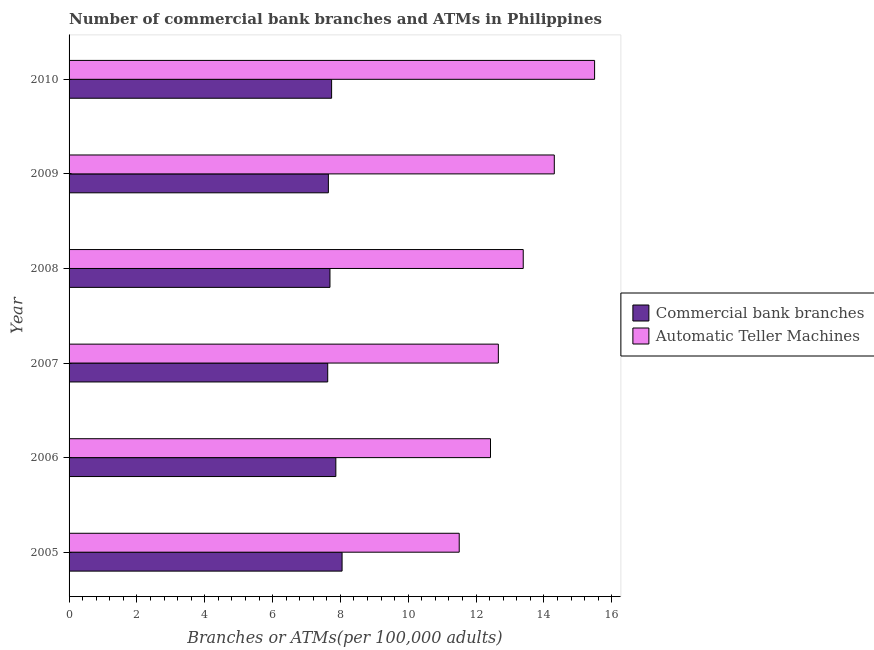How many different coloured bars are there?
Provide a succinct answer. 2. How many groups of bars are there?
Your answer should be very brief. 6. In how many cases, is the number of bars for a given year not equal to the number of legend labels?
Provide a short and direct response. 0. What is the number of commercal bank branches in 2009?
Make the answer very short. 7.65. Across all years, what is the maximum number of commercal bank branches?
Ensure brevity in your answer.  8.05. Across all years, what is the minimum number of commercal bank branches?
Your response must be concise. 7.63. In which year was the number of atms minimum?
Give a very brief answer. 2005. What is the total number of commercal bank branches in the graph?
Provide a succinct answer. 46.62. What is the difference between the number of commercal bank branches in 2008 and that in 2010?
Ensure brevity in your answer.  -0.05. What is the difference between the number of commercal bank branches in 2010 and the number of atms in 2009?
Make the answer very short. -6.57. What is the average number of commercal bank branches per year?
Your response must be concise. 7.77. In the year 2010, what is the difference between the number of commercal bank branches and number of atms?
Give a very brief answer. -7.75. In how many years, is the number of commercal bank branches greater than 15.6 ?
Provide a succinct answer. 0. What is the ratio of the number of atms in 2009 to that in 2010?
Offer a very short reply. 0.92. What is the difference between the highest and the second highest number of commercal bank branches?
Provide a succinct answer. 0.18. What is the difference between the highest and the lowest number of commercal bank branches?
Offer a terse response. 0.42. In how many years, is the number of commercal bank branches greater than the average number of commercal bank branches taken over all years?
Offer a very short reply. 2. Is the sum of the number of atms in 2008 and 2010 greater than the maximum number of commercal bank branches across all years?
Offer a very short reply. Yes. What does the 2nd bar from the top in 2006 represents?
Provide a short and direct response. Commercial bank branches. What does the 1st bar from the bottom in 2005 represents?
Provide a succinct answer. Commercial bank branches. How many bars are there?
Provide a short and direct response. 12. Are all the bars in the graph horizontal?
Keep it short and to the point. Yes. Does the graph contain any zero values?
Make the answer very short. No. Where does the legend appear in the graph?
Your answer should be very brief. Center right. How are the legend labels stacked?
Ensure brevity in your answer.  Vertical. What is the title of the graph?
Your response must be concise. Number of commercial bank branches and ATMs in Philippines. Does "Central government" appear as one of the legend labels in the graph?
Your answer should be very brief. No. What is the label or title of the X-axis?
Ensure brevity in your answer.  Branches or ATMs(per 100,0 adults). What is the Branches or ATMs(per 100,000 adults) in Commercial bank branches in 2005?
Your response must be concise. 8.05. What is the Branches or ATMs(per 100,000 adults) of Automatic Teller Machines in 2005?
Your answer should be compact. 11.5. What is the Branches or ATMs(per 100,000 adults) in Commercial bank branches in 2006?
Give a very brief answer. 7.87. What is the Branches or ATMs(per 100,000 adults) of Automatic Teller Machines in 2006?
Your answer should be compact. 12.43. What is the Branches or ATMs(per 100,000 adults) of Commercial bank branches in 2007?
Offer a terse response. 7.63. What is the Branches or ATMs(per 100,000 adults) in Automatic Teller Machines in 2007?
Your answer should be very brief. 12.66. What is the Branches or ATMs(per 100,000 adults) of Commercial bank branches in 2008?
Provide a short and direct response. 7.69. What is the Branches or ATMs(per 100,000 adults) in Automatic Teller Machines in 2008?
Provide a short and direct response. 13.39. What is the Branches or ATMs(per 100,000 adults) in Commercial bank branches in 2009?
Your answer should be very brief. 7.65. What is the Branches or ATMs(per 100,000 adults) of Automatic Teller Machines in 2009?
Ensure brevity in your answer.  14.31. What is the Branches or ATMs(per 100,000 adults) in Commercial bank branches in 2010?
Give a very brief answer. 7.74. What is the Branches or ATMs(per 100,000 adults) in Automatic Teller Machines in 2010?
Offer a terse response. 15.49. Across all years, what is the maximum Branches or ATMs(per 100,000 adults) of Commercial bank branches?
Ensure brevity in your answer.  8.05. Across all years, what is the maximum Branches or ATMs(per 100,000 adults) in Automatic Teller Machines?
Your response must be concise. 15.49. Across all years, what is the minimum Branches or ATMs(per 100,000 adults) of Commercial bank branches?
Ensure brevity in your answer.  7.63. Across all years, what is the minimum Branches or ATMs(per 100,000 adults) of Automatic Teller Machines?
Your answer should be compact. 11.5. What is the total Branches or ATMs(per 100,000 adults) in Commercial bank branches in the graph?
Provide a short and direct response. 46.62. What is the total Branches or ATMs(per 100,000 adults) of Automatic Teller Machines in the graph?
Make the answer very short. 79.78. What is the difference between the Branches or ATMs(per 100,000 adults) of Commercial bank branches in 2005 and that in 2006?
Keep it short and to the point. 0.18. What is the difference between the Branches or ATMs(per 100,000 adults) in Automatic Teller Machines in 2005 and that in 2006?
Offer a very short reply. -0.92. What is the difference between the Branches or ATMs(per 100,000 adults) in Commercial bank branches in 2005 and that in 2007?
Give a very brief answer. 0.42. What is the difference between the Branches or ATMs(per 100,000 adults) of Automatic Teller Machines in 2005 and that in 2007?
Your answer should be very brief. -1.15. What is the difference between the Branches or ATMs(per 100,000 adults) in Commercial bank branches in 2005 and that in 2008?
Give a very brief answer. 0.36. What is the difference between the Branches or ATMs(per 100,000 adults) in Automatic Teller Machines in 2005 and that in 2008?
Your answer should be very brief. -1.89. What is the difference between the Branches or ATMs(per 100,000 adults) of Commercial bank branches in 2005 and that in 2009?
Provide a succinct answer. 0.4. What is the difference between the Branches or ATMs(per 100,000 adults) in Automatic Teller Machines in 2005 and that in 2009?
Provide a short and direct response. -2.8. What is the difference between the Branches or ATMs(per 100,000 adults) in Commercial bank branches in 2005 and that in 2010?
Provide a short and direct response. 0.31. What is the difference between the Branches or ATMs(per 100,000 adults) in Automatic Teller Machines in 2005 and that in 2010?
Ensure brevity in your answer.  -3.99. What is the difference between the Branches or ATMs(per 100,000 adults) in Commercial bank branches in 2006 and that in 2007?
Make the answer very short. 0.24. What is the difference between the Branches or ATMs(per 100,000 adults) of Automatic Teller Machines in 2006 and that in 2007?
Make the answer very short. -0.23. What is the difference between the Branches or ATMs(per 100,000 adults) in Commercial bank branches in 2006 and that in 2008?
Offer a terse response. 0.17. What is the difference between the Branches or ATMs(per 100,000 adults) in Automatic Teller Machines in 2006 and that in 2008?
Provide a short and direct response. -0.96. What is the difference between the Branches or ATMs(per 100,000 adults) in Commercial bank branches in 2006 and that in 2009?
Give a very brief answer. 0.22. What is the difference between the Branches or ATMs(per 100,000 adults) of Automatic Teller Machines in 2006 and that in 2009?
Offer a very short reply. -1.88. What is the difference between the Branches or ATMs(per 100,000 adults) in Automatic Teller Machines in 2006 and that in 2010?
Your answer should be very brief. -3.07. What is the difference between the Branches or ATMs(per 100,000 adults) in Commercial bank branches in 2007 and that in 2008?
Keep it short and to the point. -0.07. What is the difference between the Branches or ATMs(per 100,000 adults) of Automatic Teller Machines in 2007 and that in 2008?
Ensure brevity in your answer.  -0.73. What is the difference between the Branches or ATMs(per 100,000 adults) of Commercial bank branches in 2007 and that in 2009?
Offer a very short reply. -0.02. What is the difference between the Branches or ATMs(per 100,000 adults) in Automatic Teller Machines in 2007 and that in 2009?
Offer a very short reply. -1.65. What is the difference between the Branches or ATMs(per 100,000 adults) in Commercial bank branches in 2007 and that in 2010?
Give a very brief answer. -0.11. What is the difference between the Branches or ATMs(per 100,000 adults) in Automatic Teller Machines in 2007 and that in 2010?
Provide a short and direct response. -2.84. What is the difference between the Branches or ATMs(per 100,000 adults) of Commercial bank branches in 2008 and that in 2009?
Make the answer very short. 0.05. What is the difference between the Branches or ATMs(per 100,000 adults) of Automatic Teller Machines in 2008 and that in 2009?
Your answer should be compact. -0.92. What is the difference between the Branches or ATMs(per 100,000 adults) of Commercial bank branches in 2008 and that in 2010?
Offer a terse response. -0.05. What is the difference between the Branches or ATMs(per 100,000 adults) in Automatic Teller Machines in 2008 and that in 2010?
Ensure brevity in your answer.  -2.1. What is the difference between the Branches or ATMs(per 100,000 adults) in Commercial bank branches in 2009 and that in 2010?
Give a very brief answer. -0.1. What is the difference between the Branches or ATMs(per 100,000 adults) in Automatic Teller Machines in 2009 and that in 2010?
Your answer should be very brief. -1.19. What is the difference between the Branches or ATMs(per 100,000 adults) of Commercial bank branches in 2005 and the Branches or ATMs(per 100,000 adults) of Automatic Teller Machines in 2006?
Your answer should be compact. -4.38. What is the difference between the Branches or ATMs(per 100,000 adults) of Commercial bank branches in 2005 and the Branches or ATMs(per 100,000 adults) of Automatic Teller Machines in 2007?
Your answer should be very brief. -4.61. What is the difference between the Branches or ATMs(per 100,000 adults) in Commercial bank branches in 2005 and the Branches or ATMs(per 100,000 adults) in Automatic Teller Machines in 2008?
Your response must be concise. -5.34. What is the difference between the Branches or ATMs(per 100,000 adults) of Commercial bank branches in 2005 and the Branches or ATMs(per 100,000 adults) of Automatic Teller Machines in 2009?
Provide a succinct answer. -6.26. What is the difference between the Branches or ATMs(per 100,000 adults) of Commercial bank branches in 2005 and the Branches or ATMs(per 100,000 adults) of Automatic Teller Machines in 2010?
Ensure brevity in your answer.  -7.44. What is the difference between the Branches or ATMs(per 100,000 adults) of Commercial bank branches in 2006 and the Branches or ATMs(per 100,000 adults) of Automatic Teller Machines in 2007?
Provide a short and direct response. -4.79. What is the difference between the Branches or ATMs(per 100,000 adults) of Commercial bank branches in 2006 and the Branches or ATMs(per 100,000 adults) of Automatic Teller Machines in 2008?
Provide a short and direct response. -5.52. What is the difference between the Branches or ATMs(per 100,000 adults) of Commercial bank branches in 2006 and the Branches or ATMs(per 100,000 adults) of Automatic Teller Machines in 2009?
Offer a terse response. -6.44. What is the difference between the Branches or ATMs(per 100,000 adults) of Commercial bank branches in 2006 and the Branches or ATMs(per 100,000 adults) of Automatic Teller Machines in 2010?
Offer a terse response. -7.63. What is the difference between the Branches or ATMs(per 100,000 adults) in Commercial bank branches in 2007 and the Branches or ATMs(per 100,000 adults) in Automatic Teller Machines in 2008?
Give a very brief answer. -5.76. What is the difference between the Branches or ATMs(per 100,000 adults) in Commercial bank branches in 2007 and the Branches or ATMs(per 100,000 adults) in Automatic Teller Machines in 2009?
Offer a terse response. -6.68. What is the difference between the Branches or ATMs(per 100,000 adults) in Commercial bank branches in 2007 and the Branches or ATMs(per 100,000 adults) in Automatic Teller Machines in 2010?
Your answer should be very brief. -7.87. What is the difference between the Branches or ATMs(per 100,000 adults) in Commercial bank branches in 2008 and the Branches or ATMs(per 100,000 adults) in Automatic Teller Machines in 2009?
Provide a succinct answer. -6.61. What is the difference between the Branches or ATMs(per 100,000 adults) in Commercial bank branches in 2008 and the Branches or ATMs(per 100,000 adults) in Automatic Teller Machines in 2010?
Keep it short and to the point. -7.8. What is the difference between the Branches or ATMs(per 100,000 adults) of Commercial bank branches in 2009 and the Branches or ATMs(per 100,000 adults) of Automatic Teller Machines in 2010?
Ensure brevity in your answer.  -7.85. What is the average Branches or ATMs(per 100,000 adults) in Commercial bank branches per year?
Keep it short and to the point. 7.77. What is the average Branches or ATMs(per 100,000 adults) in Automatic Teller Machines per year?
Ensure brevity in your answer.  13.3. In the year 2005, what is the difference between the Branches or ATMs(per 100,000 adults) of Commercial bank branches and Branches or ATMs(per 100,000 adults) of Automatic Teller Machines?
Give a very brief answer. -3.45. In the year 2006, what is the difference between the Branches or ATMs(per 100,000 adults) in Commercial bank branches and Branches or ATMs(per 100,000 adults) in Automatic Teller Machines?
Make the answer very short. -4.56. In the year 2007, what is the difference between the Branches or ATMs(per 100,000 adults) of Commercial bank branches and Branches or ATMs(per 100,000 adults) of Automatic Teller Machines?
Ensure brevity in your answer.  -5.03. In the year 2008, what is the difference between the Branches or ATMs(per 100,000 adults) in Commercial bank branches and Branches or ATMs(per 100,000 adults) in Automatic Teller Machines?
Give a very brief answer. -5.7. In the year 2009, what is the difference between the Branches or ATMs(per 100,000 adults) of Commercial bank branches and Branches or ATMs(per 100,000 adults) of Automatic Teller Machines?
Offer a very short reply. -6.66. In the year 2010, what is the difference between the Branches or ATMs(per 100,000 adults) in Commercial bank branches and Branches or ATMs(per 100,000 adults) in Automatic Teller Machines?
Keep it short and to the point. -7.75. What is the ratio of the Branches or ATMs(per 100,000 adults) of Commercial bank branches in 2005 to that in 2006?
Offer a terse response. 1.02. What is the ratio of the Branches or ATMs(per 100,000 adults) in Automatic Teller Machines in 2005 to that in 2006?
Keep it short and to the point. 0.93. What is the ratio of the Branches or ATMs(per 100,000 adults) in Commercial bank branches in 2005 to that in 2007?
Keep it short and to the point. 1.06. What is the ratio of the Branches or ATMs(per 100,000 adults) in Automatic Teller Machines in 2005 to that in 2007?
Provide a succinct answer. 0.91. What is the ratio of the Branches or ATMs(per 100,000 adults) of Commercial bank branches in 2005 to that in 2008?
Ensure brevity in your answer.  1.05. What is the ratio of the Branches or ATMs(per 100,000 adults) of Automatic Teller Machines in 2005 to that in 2008?
Provide a short and direct response. 0.86. What is the ratio of the Branches or ATMs(per 100,000 adults) of Commercial bank branches in 2005 to that in 2009?
Give a very brief answer. 1.05. What is the ratio of the Branches or ATMs(per 100,000 adults) of Automatic Teller Machines in 2005 to that in 2009?
Provide a succinct answer. 0.8. What is the ratio of the Branches or ATMs(per 100,000 adults) of Commercial bank branches in 2005 to that in 2010?
Give a very brief answer. 1.04. What is the ratio of the Branches or ATMs(per 100,000 adults) in Automatic Teller Machines in 2005 to that in 2010?
Your response must be concise. 0.74. What is the ratio of the Branches or ATMs(per 100,000 adults) in Commercial bank branches in 2006 to that in 2007?
Your answer should be very brief. 1.03. What is the ratio of the Branches or ATMs(per 100,000 adults) of Automatic Teller Machines in 2006 to that in 2007?
Provide a succinct answer. 0.98. What is the ratio of the Branches or ATMs(per 100,000 adults) of Commercial bank branches in 2006 to that in 2008?
Provide a succinct answer. 1.02. What is the ratio of the Branches or ATMs(per 100,000 adults) in Automatic Teller Machines in 2006 to that in 2008?
Give a very brief answer. 0.93. What is the ratio of the Branches or ATMs(per 100,000 adults) of Commercial bank branches in 2006 to that in 2009?
Provide a succinct answer. 1.03. What is the ratio of the Branches or ATMs(per 100,000 adults) in Automatic Teller Machines in 2006 to that in 2009?
Ensure brevity in your answer.  0.87. What is the ratio of the Branches or ATMs(per 100,000 adults) in Commercial bank branches in 2006 to that in 2010?
Offer a very short reply. 1.02. What is the ratio of the Branches or ATMs(per 100,000 adults) of Automatic Teller Machines in 2006 to that in 2010?
Offer a terse response. 0.8. What is the ratio of the Branches or ATMs(per 100,000 adults) of Automatic Teller Machines in 2007 to that in 2008?
Give a very brief answer. 0.95. What is the ratio of the Branches or ATMs(per 100,000 adults) of Commercial bank branches in 2007 to that in 2009?
Keep it short and to the point. 1. What is the ratio of the Branches or ATMs(per 100,000 adults) in Automatic Teller Machines in 2007 to that in 2009?
Provide a succinct answer. 0.88. What is the ratio of the Branches or ATMs(per 100,000 adults) in Commercial bank branches in 2007 to that in 2010?
Offer a very short reply. 0.99. What is the ratio of the Branches or ATMs(per 100,000 adults) of Automatic Teller Machines in 2007 to that in 2010?
Make the answer very short. 0.82. What is the ratio of the Branches or ATMs(per 100,000 adults) of Automatic Teller Machines in 2008 to that in 2009?
Ensure brevity in your answer.  0.94. What is the ratio of the Branches or ATMs(per 100,000 adults) in Commercial bank branches in 2008 to that in 2010?
Keep it short and to the point. 0.99. What is the ratio of the Branches or ATMs(per 100,000 adults) in Automatic Teller Machines in 2008 to that in 2010?
Give a very brief answer. 0.86. What is the ratio of the Branches or ATMs(per 100,000 adults) in Commercial bank branches in 2009 to that in 2010?
Give a very brief answer. 0.99. What is the ratio of the Branches or ATMs(per 100,000 adults) in Automatic Teller Machines in 2009 to that in 2010?
Offer a terse response. 0.92. What is the difference between the highest and the second highest Branches or ATMs(per 100,000 adults) of Commercial bank branches?
Offer a terse response. 0.18. What is the difference between the highest and the second highest Branches or ATMs(per 100,000 adults) of Automatic Teller Machines?
Your answer should be compact. 1.19. What is the difference between the highest and the lowest Branches or ATMs(per 100,000 adults) of Commercial bank branches?
Provide a short and direct response. 0.42. What is the difference between the highest and the lowest Branches or ATMs(per 100,000 adults) in Automatic Teller Machines?
Keep it short and to the point. 3.99. 